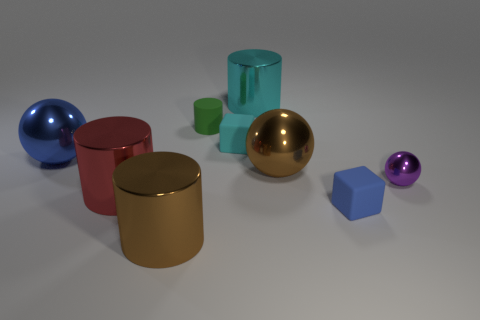What is the material of the big sphere that is to the right of the ball on the left side of the brown metal cylinder?
Your answer should be compact. Metal. There is a big blue object; is its shape the same as the purple metal object in front of the large blue ball?
Keep it short and to the point. Yes. What number of metal things are red objects or large green blocks?
Make the answer very short. 1. What is the color of the sphere that is in front of the large brown shiny object that is behind the rubber object that is in front of the purple metallic thing?
Make the answer very short. Purple. How many other objects are the same material as the large brown sphere?
Your response must be concise. 5. There is a brown shiny thing that is behind the red shiny object; is its shape the same as the tiny cyan matte thing?
Ensure brevity in your answer.  No. What number of big things are yellow things or red metallic cylinders?
Give a very brief answer. 1. Is the number of cyan cylinders in front of the large blue shiny thing the same as the number of tiny green matte cylinders that are right of the green object?
Provide a short and direct response. Yes. How many other things are there of the same color as the rubber cylinder?
Your answer should be compact. 0. What number of purple objects are tiny matte cubes or matte cylinders?
Give a very brief answer. 0. 